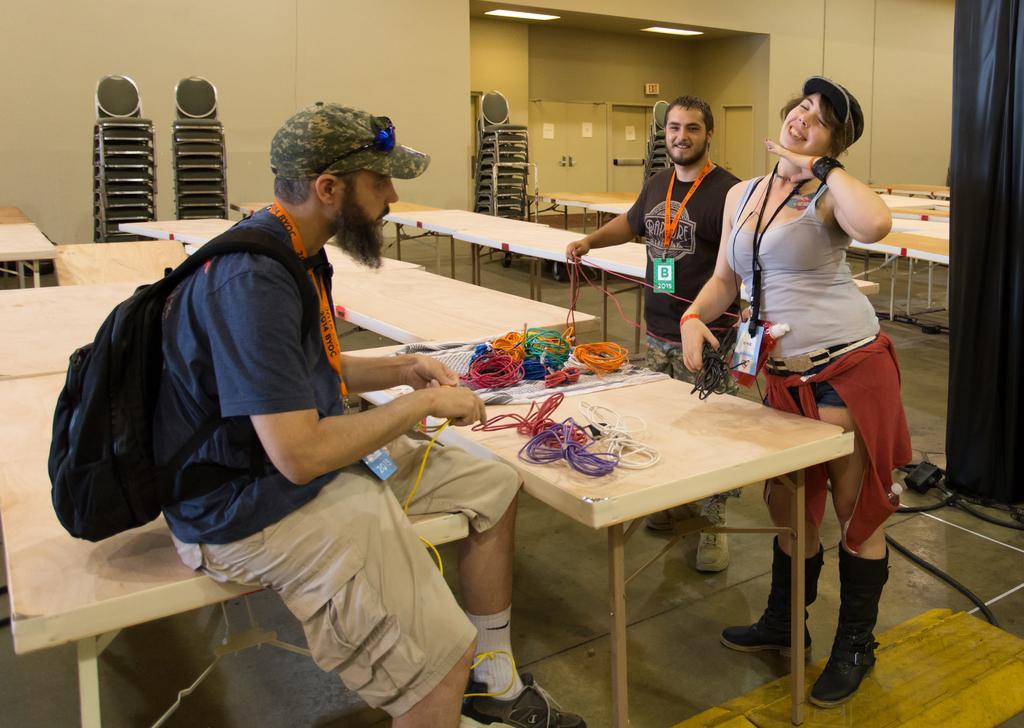Could you give a brief overview of what you see in this image? In this image I see 2 men and a woman and there are lot of tables and chairs. I can also see that these both are smiling and there are few things on this table. 